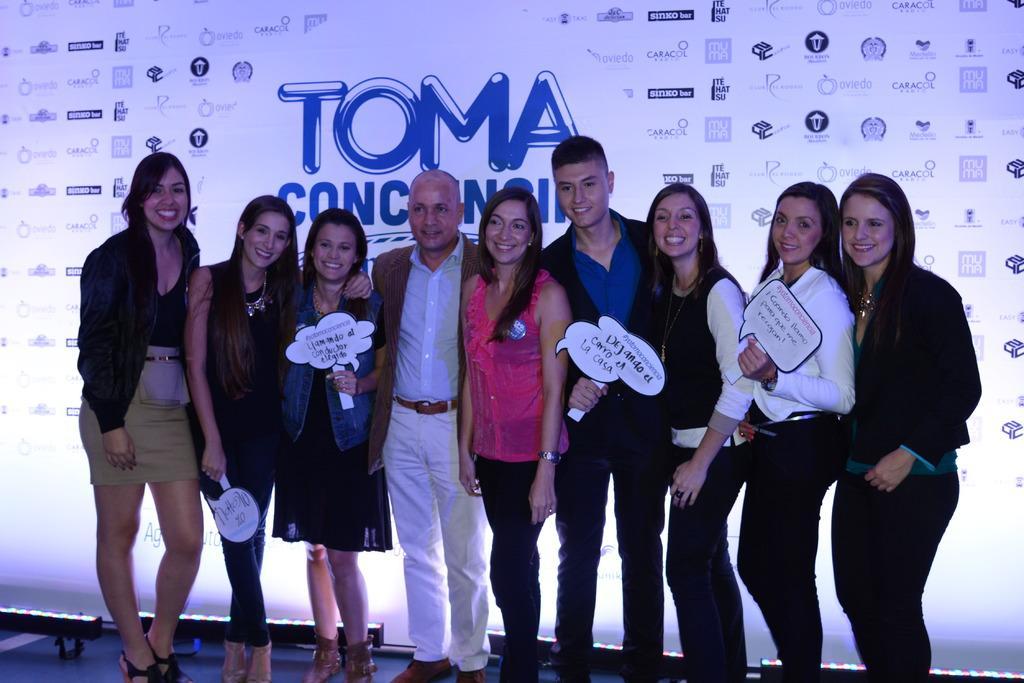How would you summarize this image in a sentence or two? In this image we can see many persons standing on the ground. In the background there is an advertisement. 